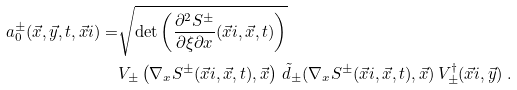Convert formula to latex. <formula><loc_0><loc_0><loc_500><loc_500>a _ { 0 } ^ { \pm } ( \vec { x } , \vec { y } , t , \vec { x } i ) = & \sqrt { \det \left ( \frac { \partial ^ { 2 } S ^ { \pm } } { \partial \xi \partial x } ( \vec { x } i , \vec { x } , t ) \right ) } \\ & V _ { \pm } \left ( \nabla _ { x } S ^ { \pm } ( \vec { x } i , \vec { x } , t ) , \vec { x } \right ) \, \tilde { d } _ { \pm } ( \nabla _ { x } S ^ { \pm } ( \vec { x } i , \vec { x } , t ) , \vec { x } ) \, V _ { \pm } ^ { \dagger } ( \vec { x } i , \vec { y } ) \ .</formula> 